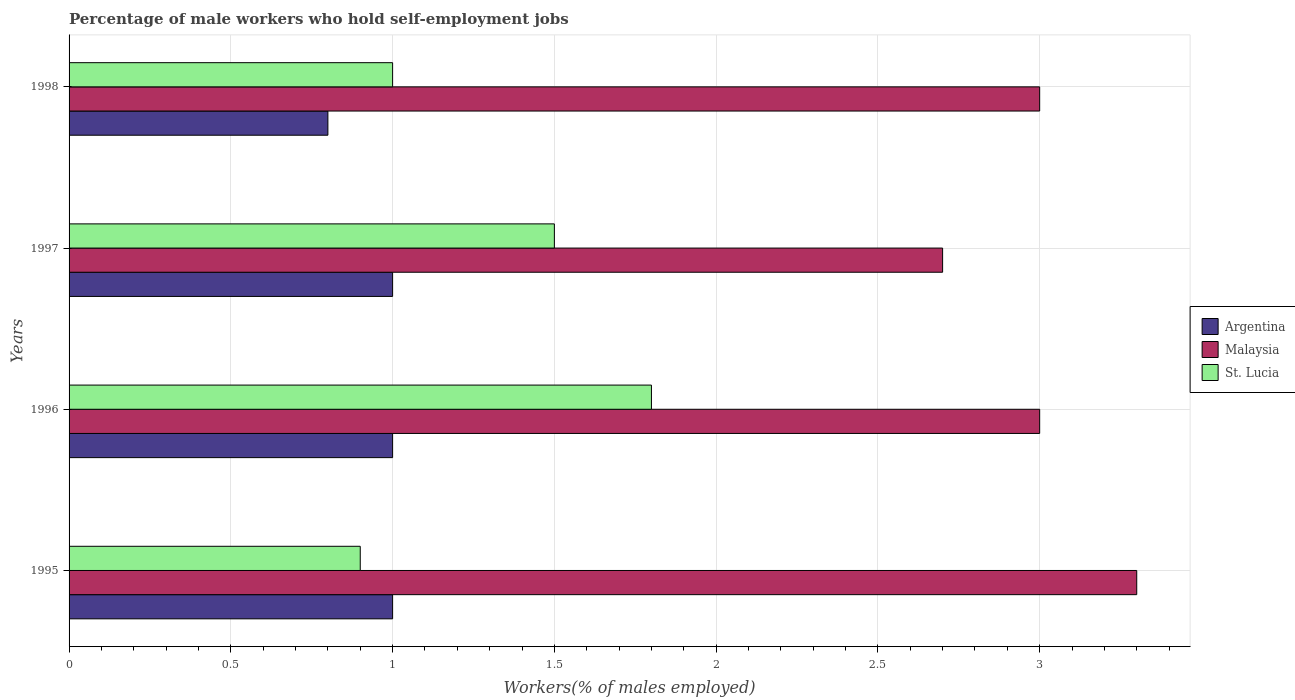How many different coloured bars are there?
Make the answer very short. 3. Are the number of bars per tick equal to the number of legend labels?
Your answer should be compact. Yes. Are the number of bars on each tick of the Y-axis equal?
Provide a short and direct response. Yes. What is the label of the 1st group of bars from the top?
Offer a very short reply. 1998. What is the percentage of self-employed male workers in Malaysia in 1997?
Offer a terse response. 2.7. Across all years, what is the minimum percentage of self-employed male workers in Argentina?
Provide a succinct answer. 0.8. In which year was the percentage of self-employed male workers in Argentina minimum?
Ensure brevity in your answer.  1998. What is the total percentage of self-employed male workers in Argentina in the graph?
Provide a succinct answer. 3.8. What is the difference between the percentage of self-employed male workers in St. Lucia in 1996 and that in 1997?
Give a very brief answer. 0.3. What is the average percentage of self-employed male workers in St. Lucia per year?
Offer a very short reply. 1.3. In the year 1995, what is the difference between the percentage of self-employed male workers in St. Lucia and percentage of self-employed male workers in Argentina?
Ensure brevity in your answer.  -0.1. In how many years, is the percentage of self-employed male workers in Argentina greater than 2.9 %?
Keep it short and to the point. 0. What is the ratio of the percentage of self-employed male workers in Malaysia in 1996 to that in 1998?
Ensure brevity in your answer.  1. What is the difference between the highest and the second highest percentage of self-employed male workers in St. Lucia?
Provide a short and direct response. 0.3. What is the difference between the highest and the lowest percentage of self-employed male workers in Malaysia?
Your answer should be compact. 0.6. In how many years, is the percentage of self-employed male workers in St. Lucia greater than the average percentage of self-employed male workers in St. Lucia taken over all years?
Ensure brevity in your answer.  2. What does the 1st bar from the top in 1997 represents?
Your response must be concise. St. Lucia. What does the 3rd bar from the bottom in 1996 represents?
Provide a succinct answer. St. Lucia. Is it the case that in every year, the sum of the percentage of self-employed male workers in Argentina and percentage of self-employed male workers in Malaysia is greater than the percentage of self-employed male workers in St. Lucia?
Your answer should be very brief. Yes. Are all the bars in the graph horizontal?
Offer a very short reply. Yes. How many years are there in the graph?
Provide a short and direct response. 4. What is the difference between two consecutive major ticks on the X-axis?
Make the answer very short. 0.5. Does the graph contain any zero values?
Offer a terse response. No. How many legend labels are there?
Make the answer very short. 3. How are the legend labels stacked?
Your response must be concise. Vertical. What is the title of the graph?
Your answer should be very brief. Percentage of male workers who hold self-employment jobs. Does "Antigua and Barbuda" appear as one of the legend labels in the graph?
Ensure brevity in your answer.  No. What is the label or title of the X-axis?
Your response must be concise. Workers(% of males employed). What is the Workers(% of males employed) of Malaysia in 1995?
Your answer should be very brief. 3.3. What is the Workers(% of males employed) of St. Lucia in 1995?
Provide a succinct answer. 0.9. What is the Workers(% of males employed) of St. Lucia in 1996?
Offer a terse response. 1.8. What is the Workers(% of males employed) of Malaysia in 1997?
Your answer should be compact. 2.7. What is the Workers(% of males employed) in Argentina in 1998?
Offer a very short reply. 0.8. What is the Workers(% of males employed) in Malaysia in 1998?
Offer a very short reply. 3. Across all years, what is the maximum Workers(% of males employed) in Argentina?
Keep it short and to the point. 1. Across all years, what is the maximum Workers(% of males employed) of Malaysia?
Your response must be concise. 3.3. Across all years, what is the maximum Workers(% of males employed) in St. Lucia?
Your answer should be compact. 1.8. Across all years, what is the minimum Workers(% of males employed) of Argentina?
Your answer should be compact. 0.8. Across all years, what is the minimum Workers(% of males employed) in Malaysia?
Offer a terse response. 2.7. Across all years, what is the minimum Workers(% of males employed) in St. Lucia?
Provide a short and direct response. 0.9. What is the total Workers(% of males employed) in Argentina in the graph?
Provide a short and direct response. 3.8. What is the difference between the Workers(% of males employed) of Argentina in 1995 and that in 1996?
Offer a very short reply. 0. What is the difference between the Workers(% of males employed) of Malaysia in 1995 and that in 1996?
Offer a terse response. 0.3. What is the difference between the Workers(% of males employed) in St. Lucia in 1995 and that in 1996?
Make the answer very short. -0.9. What is the difference between the Workers(% of males employed) in Argentina in 1995 and that in 1997?
Keep it short and to the point. 0. What is the difference between the Workers(% of males employed) of St. Lucia in 1995 and that in 1997?
Give a very brief answer. -0.6. What is the difference between the Workers(% of males employed) in Argentina in 1995 and that in 1998?
Offer a very short reply. 0.2. What is the difference between the Workers(% of males employed) in Malaysia in 1995 and that in 1998?
Provide a short and direct response. 0.3. What is the difference between the Workers(% of males employed) of St. Lucia in 1996 and that in 1997?
Your response must be concise. 0.3. What is the difference between the Workers(% of males employed) in Argentina in 1996 and that in 1998?
Your answer should be compact. 0.2. What is the difference between the Workers(% of males employed) in St. Lucia in 1996 and that in 1998?
Ensure brevity in your answer.  0.8. What is the difference between the Workers(% of males employed) of St. Lucia in 1997 and that in 1998?
Your answer should be compact. 0.5. What is the difference between the Workers(% of males employed) in Argentina in 1995 and the Workers(% of males employed) in Malaysia in 1996?
Give a very brief answer. -2. What is the difference between the Workers(% of males employed) of Malaysia in 1995 and the Workers(% of males employed) of St. Lucia in 1996?
Provide a short and direct response. 1.5. What is the difference between the Workers(% of males employed) of Malaysia in 1995 and the Workers(% of males employed) of St. Lucia in 1997?
Offer a terse response. 1.8. What is the difference between the Workers(% of males employed) of Argentina in 1995 and the Workers(% of males employed) of Malaysia in 1998?
Your answer should be compact. -2. What is the difference between the Workers(% of males employed) of Argentina in 1995 and the Workers(% of males employed) of St. Lucia in 1998?
Your answer should be very brief. 0. What is the difference between the Workers(% of males employed) in Argentina in 1996 and the Workers(% of males employed) in St. Lucia in 1997?
Your answer should be compact. -0.5. What is the difference between the Workers(% of males employed) of Argentina in 1996 and the Workers(% of males employed) of St. Lucia in 1998?
Provide a succinct answer. 0. What is the difference between the Workers(% of males employed) of Argentina in 1997 and the Workers(% of males employed) of Malaysia in 1998?
Keep it short and to the point. -2. What is the difference between the Workers(% of males employed) of Argentina in 1997 and the Workers(% of males employed) of St. Lucia in 1998?
Make the answer very short. 0. What is the average Workers(% of males employed) of St. Lucia per year?
Provide a short and direct response. 1.3. In the year 1995, what is the difference between the Workers(% of males employed) in Argentina and Workers(% of males employed) in Malaysia?
Your answer should be compact. -2.3. In the year 1995, what is the difference between the Workers(% of males employed) of Argentina and Workers(% of males employed) of St. Lucia?
Provide a short and direct response. 0.1. In the year 1996, what is the difference between the Workers(% of males employed) of Argentina and Workers(% of males employed) of St. Lucia?
Offer a terse response. -0.8. In the year 1997, what is the difference between the Workers(% of males employed) of Argentina and Workers(% of males employed) of St. Lucia?
Offer a very short reply. -0.5. In the year 1997, what is the difference between the Workers(% of males employed) of Malaysia and Workers(% of males employed) of St. Lucia?
Give a very brief answer. 1.2. What is the ratio of the Workers(% of males employed) of Argentina in 1995 to that in 1996?
Provide a short and direct response. 1. What is the ratio of the Workers(% of males employed) of Malaysia in 1995 to that in 1996?
Your response must be concise. 1.1. What is the ratio of the Workers(% of males employed) in St. Lucia in 1995 to that in 1996?
Your answer should be compact. 0.5. What is the ratio of the Workers(% of males employed) in Argentina in 1995 to that in 1997?
Make the answer very short. 1. What is the ratio of the Workers(% of males employed) of Malaysia in 1995 to that in 1997?
Provide a succinct answer. 1.22. What is the ratio of the Workers(% of males employed) in St. Lucia in 1995 to that in 1997?
Keep it short and to the point. 0.6. What is the ratio of the Workers(% of males employed) in Argentina in 1995 to that in 1998?
Keep it short and to the point. 1.25. What is the ratio of the Workers(% of males employed) in Malaysia in 1996 to that in 1997?
Keep it short and to the point. 1.11. What is the ratio of the Workers(% of males employed) in St. Lucia in 1996 to that in 1997?
Keep it short and to the point. 1.2. What is the ratio of the Workers(% of males employed) in Malaysia in 1996 to that in 1998?
Your answer should be very brief. 1. What is the ratio of the Workers(% of males employed) in Argentina in 1997 to that in 1998?
Give a very brief answer. 1.25. What is the difference between the highest and the second highest Workers(% of males employed) in Malaysia?
Offer a terse response. 0.3. What is the difference between the highest and the second highest Workers(% of males employed) in St. Lucia?
Keep it short and to the point. 0.3. What is the difference between the highest and the lowest Workers(% of males employed) of Malaysia?
Keep it short and to the point. 0.6. 